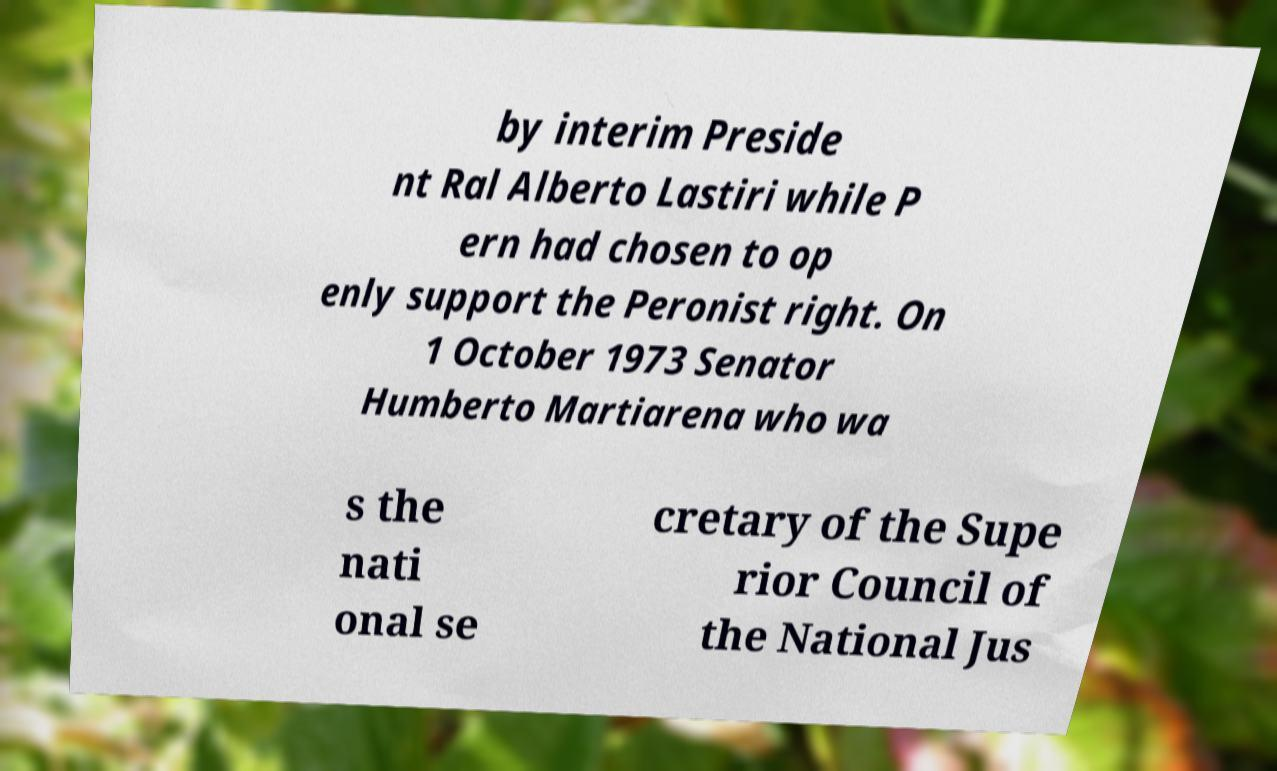What messages or text are displayed in this image? I need them in a readable, typed format. by interim Preside nt Ral Alberto Lastiri while P ern had chosen to op enly support the Peronist right. On 1 October 1973 Senator Humberto Martiarena who wa s the nati onal se cretary of the Supe rior Council of the National Jus 